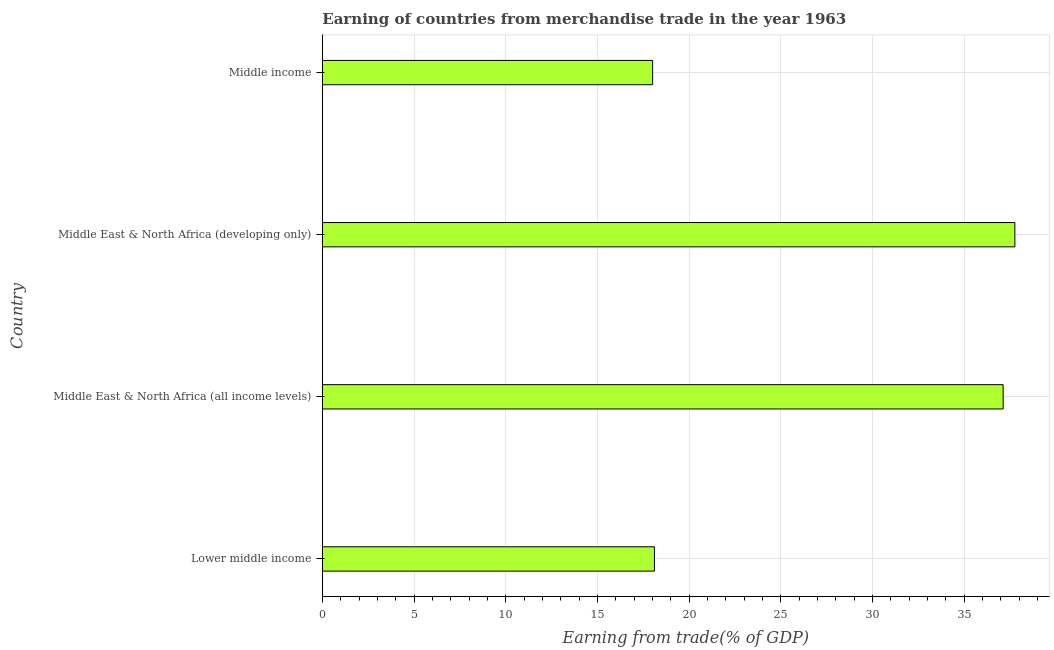Does the graph contain any zero values?
Ensure brevity in your answer.  No. What is the title of the graph?
Ensure brevity in your answer.  Earning of countries from merchandise trade in the year 1963. What is the label or title of the X-axis?
Offer a very short reply. Earning from trade(% of GDP). What is the label or title of the Y-axis?
Provide a short and direct response. Country. What is the earning from merchandise trade in Middle income?
Offer a terse response. 18.01. Across all countries, what is the maximum earning from merchandise trade?
Offer a very short reply. 37.77. Across all countries, what is the minimum earning from merchandise trade?
Ensure brevity in your answer.  18.01. In which country was the earning from merchandise trade maximum?
Ensure brevity in your answer.  Middle East & North Africa (developing only). What is the sum of the earning from merchandise trade?
Offer a very short reply. 111.03. What is the difference between the earning from merchandise trade in Middle East & North Africa (all income levels) and Middle income?
Offer a terse response. 19.12. What is the average earning from merchandise trade per country?
Provide a succinct answer. 27.76. What is the median earning from merchandise trade?
Ensure brevity in your answer.  27.62. In how many countries, is the earning from merchandise trade greater than 13 %?
Your answer should be very brief. 4. What is the ratio of the earning from merchandise trade in Lower middle income to that in Middle East & North Africa (all income levels)?
Provide a short and direct response. 0.49. Is the difference between the earning from merchandise trade in Middle East & North Africa (developing only) and Middle income greater than the difference between any two countries?
Your response must be concise. Yes. What is the difference between the highest and the second highest earning from merchandise trade?
Offer a terse response. 0.64. What is the difference between the highest and the lowest earning from merchandise trade?
Give a very brief answer. 19.76. Are all the bars in the graph horizontal?
Your response must be concise. Yes. How many countries are there in the graph?
Provide a short and direct response. 4. What is the Earning from trade(% of GDP) of Lower middle income?
Offer a terse response. 18.11. What is the Earning from trade(% of GDP) in Middle East & North Africa (all income levels)?
Provide a succinct answer. 37.13. What is the Earning from trade(% of GDP) of Middle East & North Africa (developing only)?
Provide a short and direct response. 37.77. What is the Earning from trade(% of GDP) of Middle income?
Keep it short and to the point. 18.01. What is the difference between the Earning from trade(% of GDP) in Lower middle income and Middle East & North Africa (all income levels)?
Give a very brief answer. -19.02. What is the difference between the Earning from trade(% of GDP) in Lower middle income and Middle East & North Africa (developing only)?
Your response must be concise. -19.66. What is the difference between the Earning from trade(% of GDP) in Lower middle income and Middle income?
Your response must be concise. 0.1. What is the difference between the Earning from trade(% of GDP) in Middle East & North Africa (all income levels) and Middle East & North Africa (developing only)?
Your response must be concise. -0.64. What is the difference between the Earning from trade(% of GDP) in Middle East & North Africa (all income levels) and Middle income?
Make the answer very short. 19.12. What is the difference between the Earning from trade(% of GDP) in Middle East & North Africa (developing only) and Middle income?
Your response must be concise. 19.76. What is the ratio of the Earning from trade(% of GDP) in Lower middle income to that in Middle East & North Africa (all income levels)?
Keep it short and to the point. 0.49. What is the ratio of the Earning from trade(% of GDP) in Lower middle income to that in Middle East & North Africa (developing only)?
Your answer should be very brief. 0.48. What is the ratio of the Earning from trade(% of GDP) in Lower middle income to that in Middle income?
Ensure brevity in your answer.  1. What is the ratio of the Earning from trade(% of GDP) in Middle East & North Africa (all income levels) to that in Middle East & North Africa (developing only)?
Give a very brief answer. 0.98. What is the ratio of the Earning from trade(% of GDP) in Middle East & North Africa (all income levels) to that in Middle income?
Provide a succinct answer. 2.06. What is the ratio of the Earning from trade(% of GDP) in Middle East & North Africa (developing only) to that in Middle income?
Offer a terse response. 2.1. 